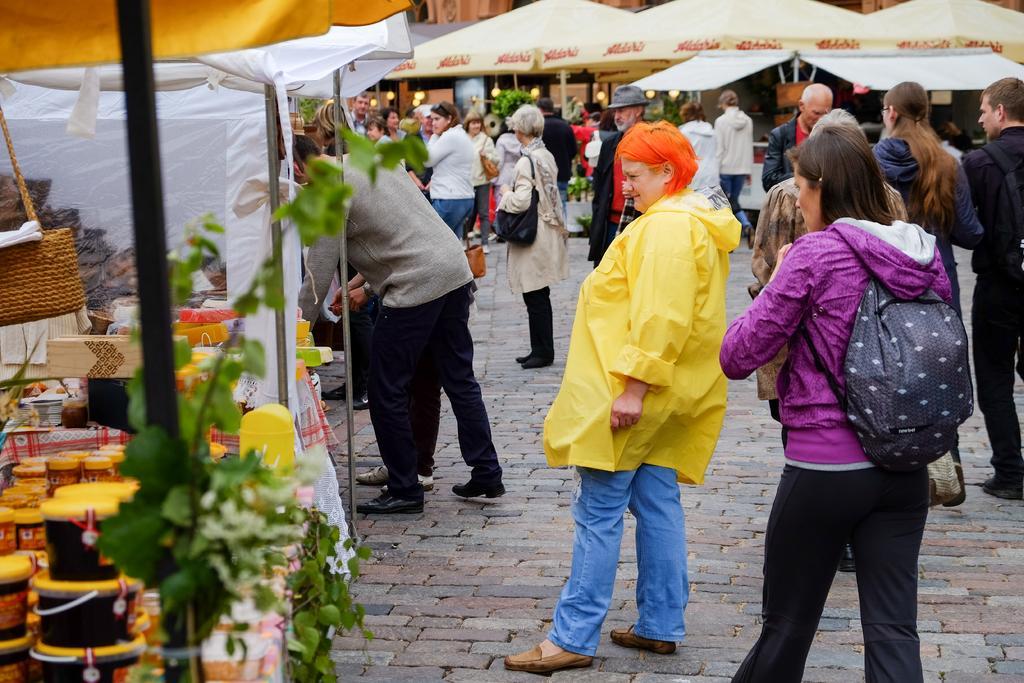How would you summarize this image in a sentence or two? Here we can see group of people on the road. There are plants, lights, boxes, bottles, poles, and umbrellas. 